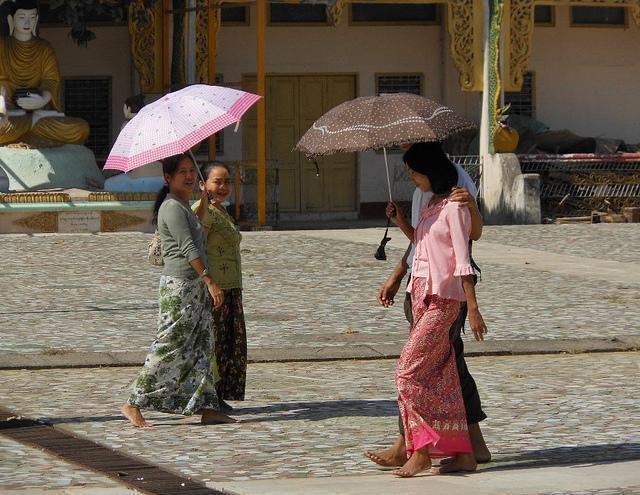Why are umbrellas being used today?
Select the accurate response from the four choices given to answer the question.
Options: Snow, rain, sun, privacy. Sun. 